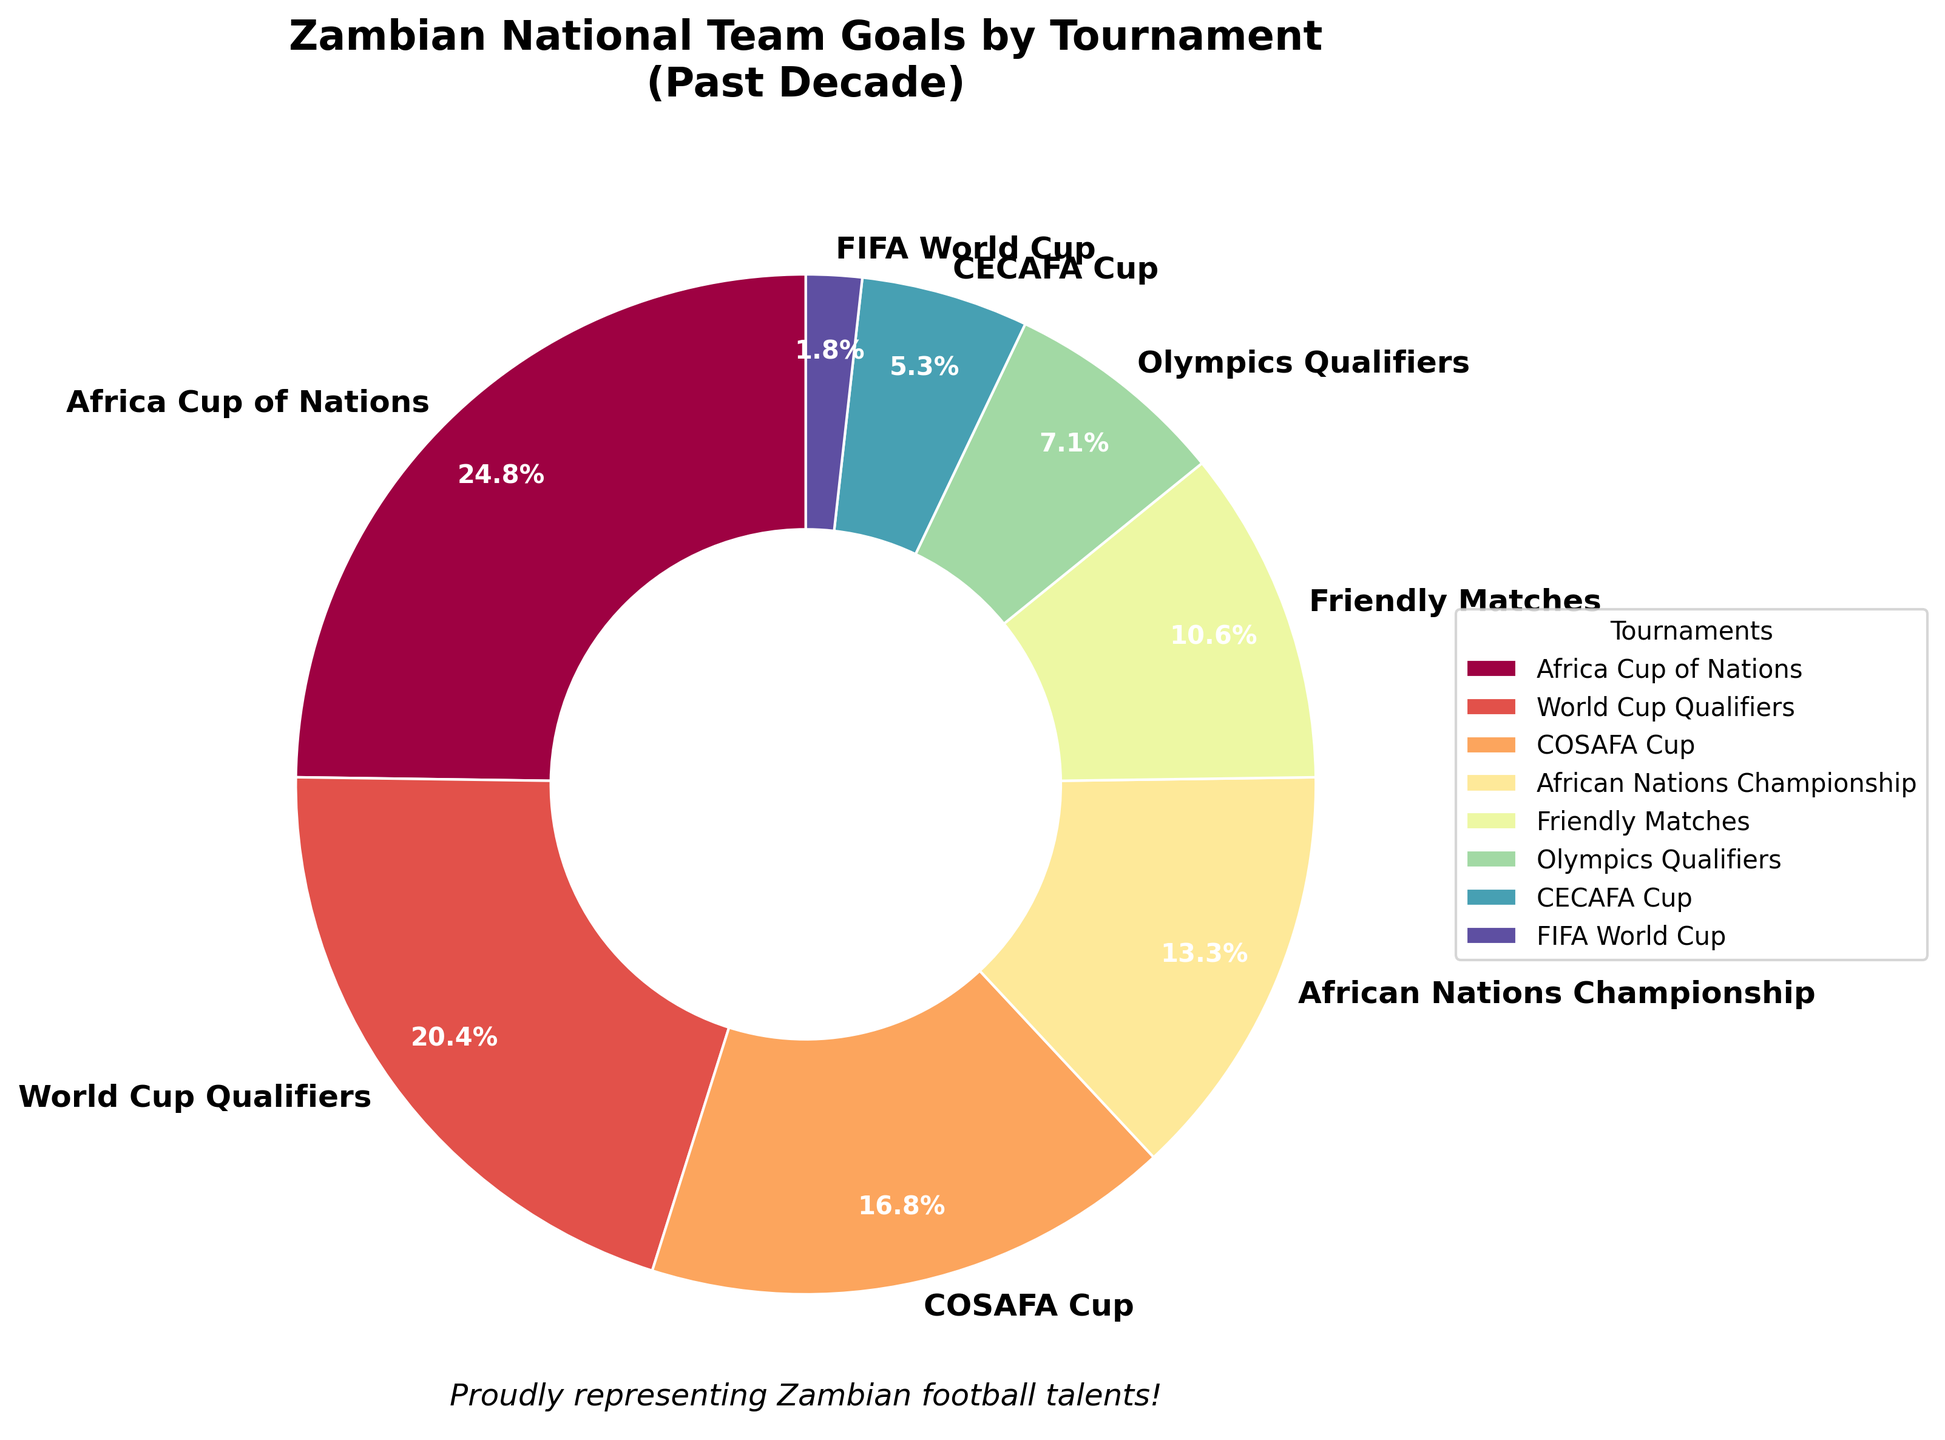Which tournament has the highest percentage of goals scored by the Zambian national team? The pie chart slice with the largest area represents the Africa Cup of Nations, which has the highest percentage of goals.
Answer: Africa Cup of Nations Which tournament accounts for the smallest percentage of goals scored by the Zambian national team? The smallest slice in the pie chart represents the FIFA World Cup.
Answer: FIFA World Cup What is the combined percentage of goals scored in the Africa Cup of Nations and the World Cup Qualifiers? The percentage for Africa Cup of Nations is 28/(28+23+19+15+12+8+6+2) * 100% = 28/113 * 100% ≈ 24.8%, and for World Cup Qualifiers 23/113 * 100% ≈ 20.4%. The combined percentage is about 24.8% + 20.4% = 45.2%.
Answer: 45.2% How many goals did Zambia score in tournaments other than Africa Cup of Nations, World Cup Qualifiers, and COSAFA Cup? Sum the goals from African Nations Championship, Friendly Matches, Olympics Qualifiers, CECAFA Cup, and FIFA World Cup. 15 + 12 + 8 + 6 + 2 = 43.
Answer: 43 Are the goals scored in Friendly Matches more than twice the goals scored in the Olympics Qualifiers? Friendly Matches have 12 goals, and Olympics Qualifiers have 8 goals. 12 is not more than twice 8 (which would be 16).
Answer: No What is the difference in the number of goals scored between the tournament with the highest goals and the tournament with the lowest goals? The highest is Africa Cup of Nations (28 goals), and the lowest is FIFA World Cup (2 goals). The difference is 28 - 2 = 26.
Answer: 26 Which tournaments have a similar percentage of goals scored? COSAFA Cup and African Nations Championship have similar percentages of goals. COSAFA Cup (19 goals) - 19/113≈ 16.8%, and African Nations Championship (15 goals) - 15/113 ≈ 13.3%.
Answer: COSAFA Cup and African Nations Championship Is the percentage of goals scored in the World Cup Qualifiers higher than the combined percentage of CECAFA Cup and Olympics Qualifiers? World Cup Qualifiers have 23 goals, which is approximately 20.4%. CECAFA Cup (6 goals) and Olympics Qualifiers (8 goals) together have 14 goals, which is 12.4%. 20.4% > 12.4%.
Answer: Yes What percentage of the goals were scored in Friendly Matches? Take the number of goals scored in Friendly Matches (12) and divide by the total number. 12/113 * 100 ≈ 10.6%.
Answer: 10.6% Are the combined goals in CECAFA Cup and FIFA World Cup more than those in Friendly Matches? CECAFA Cup (6) + FIFA World Cup (2) = 8. Friendly Matches have 12 goals. 8 < 12.
Answer: No 